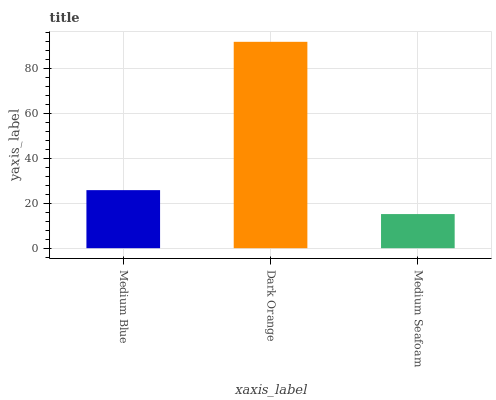Is Medium Seafoam the minimum?
Answer yes or no. Yes. Is Dark Orange the maximum?
Answer yes or no. Yes. Is Dark Orange the minimum?
Answer yes or no. No. Is Medium Seafoam the maximum?
Answer yes or no. No. Is Dark Orange greater than Medium Seafoam?
Answer yes or no. Yes. Is Medium Seafoam less than Dark Orange?
Answer yes or no. Yes. Is Medium Seafoam greater than Dark Orange?
Answer yes or no. No. Is Dark Orange less than Medium Seafoam?
Answer yes or no. No. Is Medium Blue the high median?
Answer yes or no. Yes. Is Medium Blue the low median?
Answer yes or no. Yes. Is Dark Orange the high median?
Answer yes or no. No. Is Dark Orange the low median?
Answer yes or no. No. 